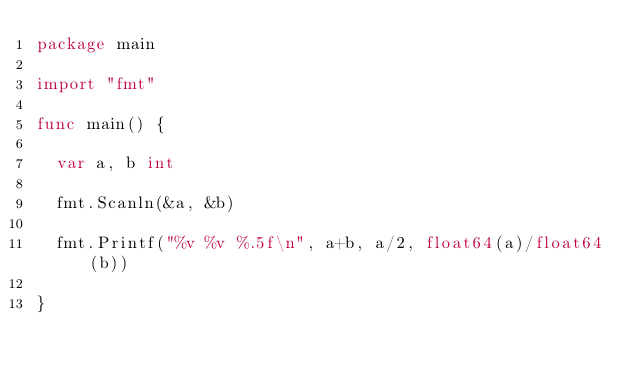<code> <loc_0><loc_0><loc_500><loc_500><_Go_>package main

import "fmt"

func main() {

	var a, b int

	fmt.Scanln(&a, &b)

	fmt.Printf("%v %v %.5f\n", a+b, a/2, float64(a)/float64(b))

}

</code> 